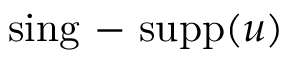Convert formula to latex. <formula><loc_0><loc_0><loc_500><loc_500>\sin g \mathrm { - } s u p p ( u )</formula> 